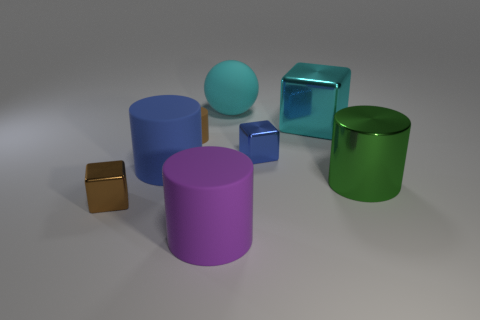Can you describe the lighting and shadows present in the scene? Certainly, the lighting in the image is coming from the upper right as evidenced by the shadows extending towards the lower left. This creates a soft shadow for each object, indicating a diffuse light source. The shadows are slightly blurred, suggesting that the light source is not extremely close to the objects. 